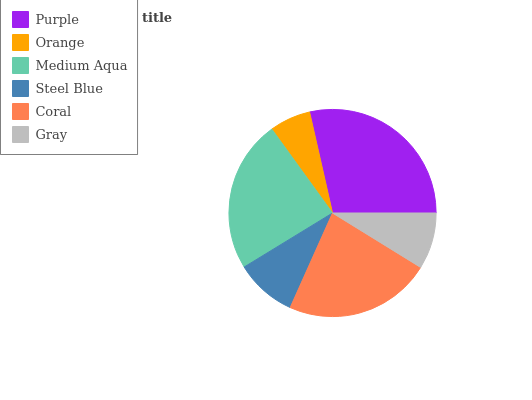Is Orange the minimum?
Answer yes or no. Yes. Is Purple the maximum?
Answer yes or no. Yes. Is Medium Aqua the minimum?
Answer yes or no. No. Is Medium Aqua the maximum?
Answer yes or no. No. Is Medium Aqua greater than Orange?
Answer yes or no. Yes. Is Orange less than Medium Aqua?
Answer yes or no. Yes. Is Orange greater than Medium Aqua?
Answer yes or no. No. Is Medium Aqua less than Orange?
Answer yes or no. No. Is Coral the high median?
Answer yes or no. Yes. Is Steel Blue the low median?
Answer yes or no. Yes. Is Purple the high median?
Answer yes or no. No. Is Orange the low median?
Answer yes or no. No. 